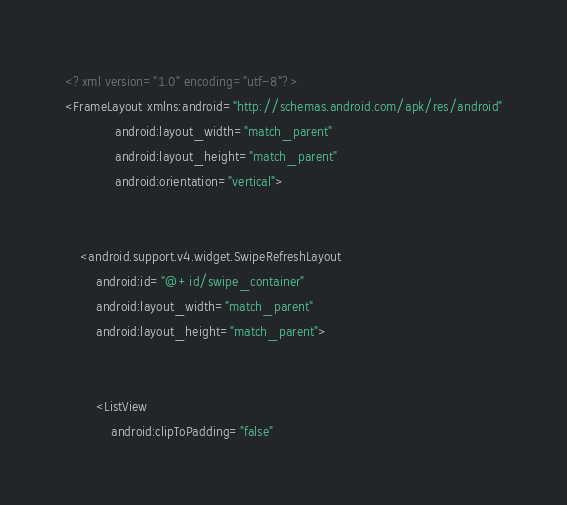Convert code to text. <code><loc_0><loc_0><loc_500><loc_500><_XML_><?xml version="1.0" encoding="utf-8"?>
<FrameLayout xmlns:android="http://schemas.android.com/apk/res/android"
             android:layout_width="match_parent"
             android:layout_height="match_parent"
             android:orientation="vertical">


    <android.support.v4.widget.SwipeRefreshLayout
        android:id="@+id/swipe_container"
        android:layout_width="match_parent"
        android:layout_height="match_parent">


        <ListView
            android:clipToPadding="false"</code> 